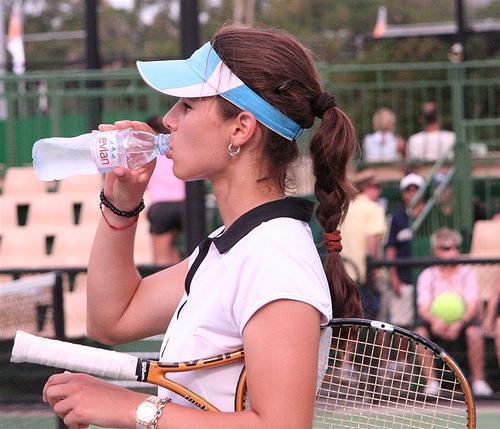How many people are there?
Give a very brief answer. 7. 